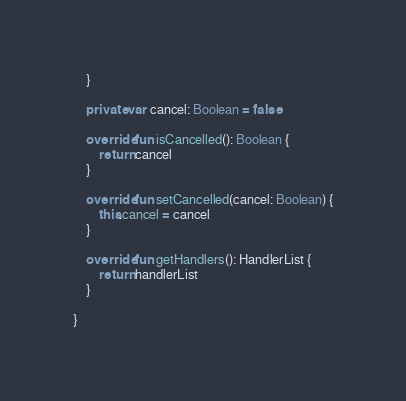Convert code to text. <code><loc_0><loc_0><loc_500><loc_500><_Kotlin_>    }

    private var cancel: Boolean = false

    override fun isCancelled(): Boolean {
        return cancel
    }

    override fun setCancelled(cancel: Boolean) {
        this.cancel = cancel
    }

    override fun getHandlers(): HandlerList {
        return handlerList
    }

}</code> 